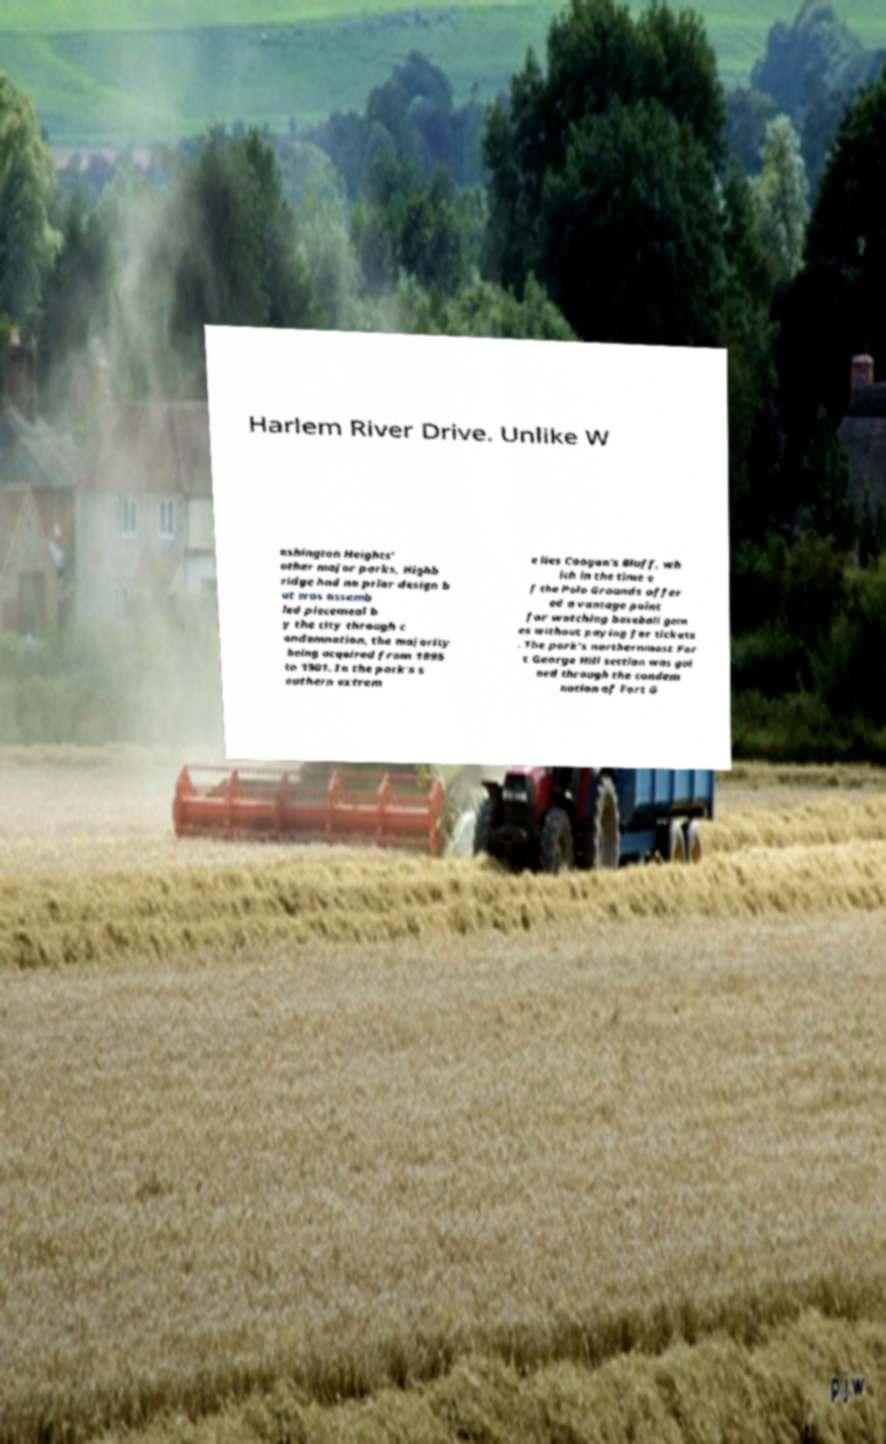Can you read and provide the text displayed in the image?This photo seems to have some interesting text. Can you extract and type it out for me? Harlem River Drive. Unlike W ashington Heights' other major parks, Highb ridge had no prior design b ut was assemb led piecemeal b y the city through c ondemnation, the majority being acquired from 1895 to 1901. In the park's s outhern extrem e lies Coogan's Bluff, wh ich in the time o f the Polo Grounds offer ed a vantage point for watching baseball gam es without paying for tickets . The park's northernmost For t George Hill section was gai ned through the condem nation of Fort G 